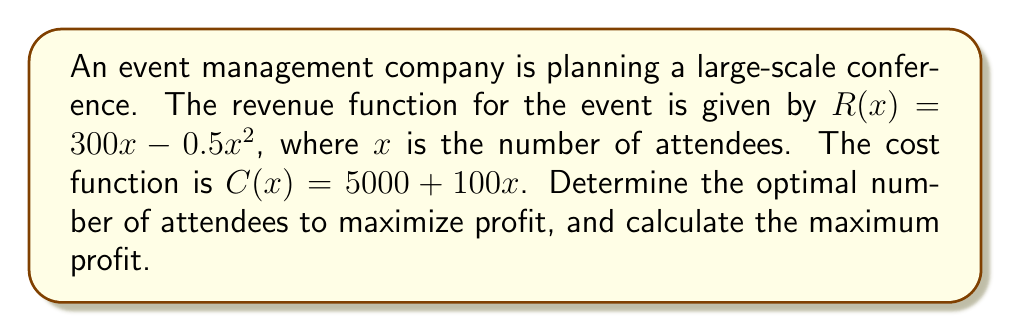Can you solve this math problem? To solve this optimization problem, we'll follow these steps:

1) First, let's define the profit function $P(x)$. Profit is revenue minus cost:

   $P(x) = R(x) - C(x) = (300x - 0.5x^2) - (5000 + 100x)$
   $P(x) = 300x - 0.5x^2 - 5000 - 100x$
   $P(x) = 200x - 0.5x^2 - 5000$

2) To find the maximum profit, we need to find where the derivative of $P(x)$ equals zero:

   $\frac{dP}{dx} = 200 - x$

3) Set this equal to zero and solve for $x$:

   $200 - x = 0$
   $x = 200$

4) To confirm this is a maximum (not a minimum), we can check the second derivative:

   $\frac{d^2P}{dx^2} = -1$

   Since this is negative, we confirm that $x = 200$ gives a maximum.

5) Now that we know the optimal number of attendees is 200, we can calculate the maximum profit:

   $P(200) = 200(200) - 0.5(200)^2 - 5000$
   $= 40000 - 20000 - 5000$
   $= 15000$

Therefore, the optimal number of attendees is 200, and the maximum profit is $15,000.
Answer: Optimal number of attendees: 200
Maximum profit: $15,000 